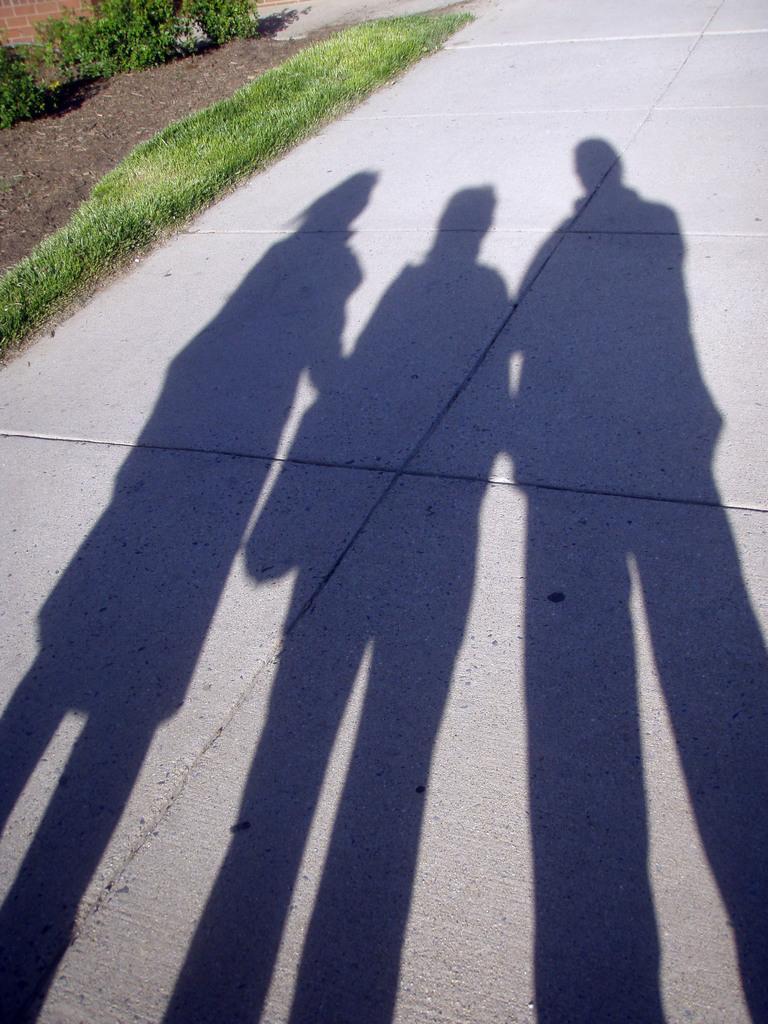Can you describe this image briefly? In this image we can see shadows of three people on the road. On the left there is grass and shrubs. 